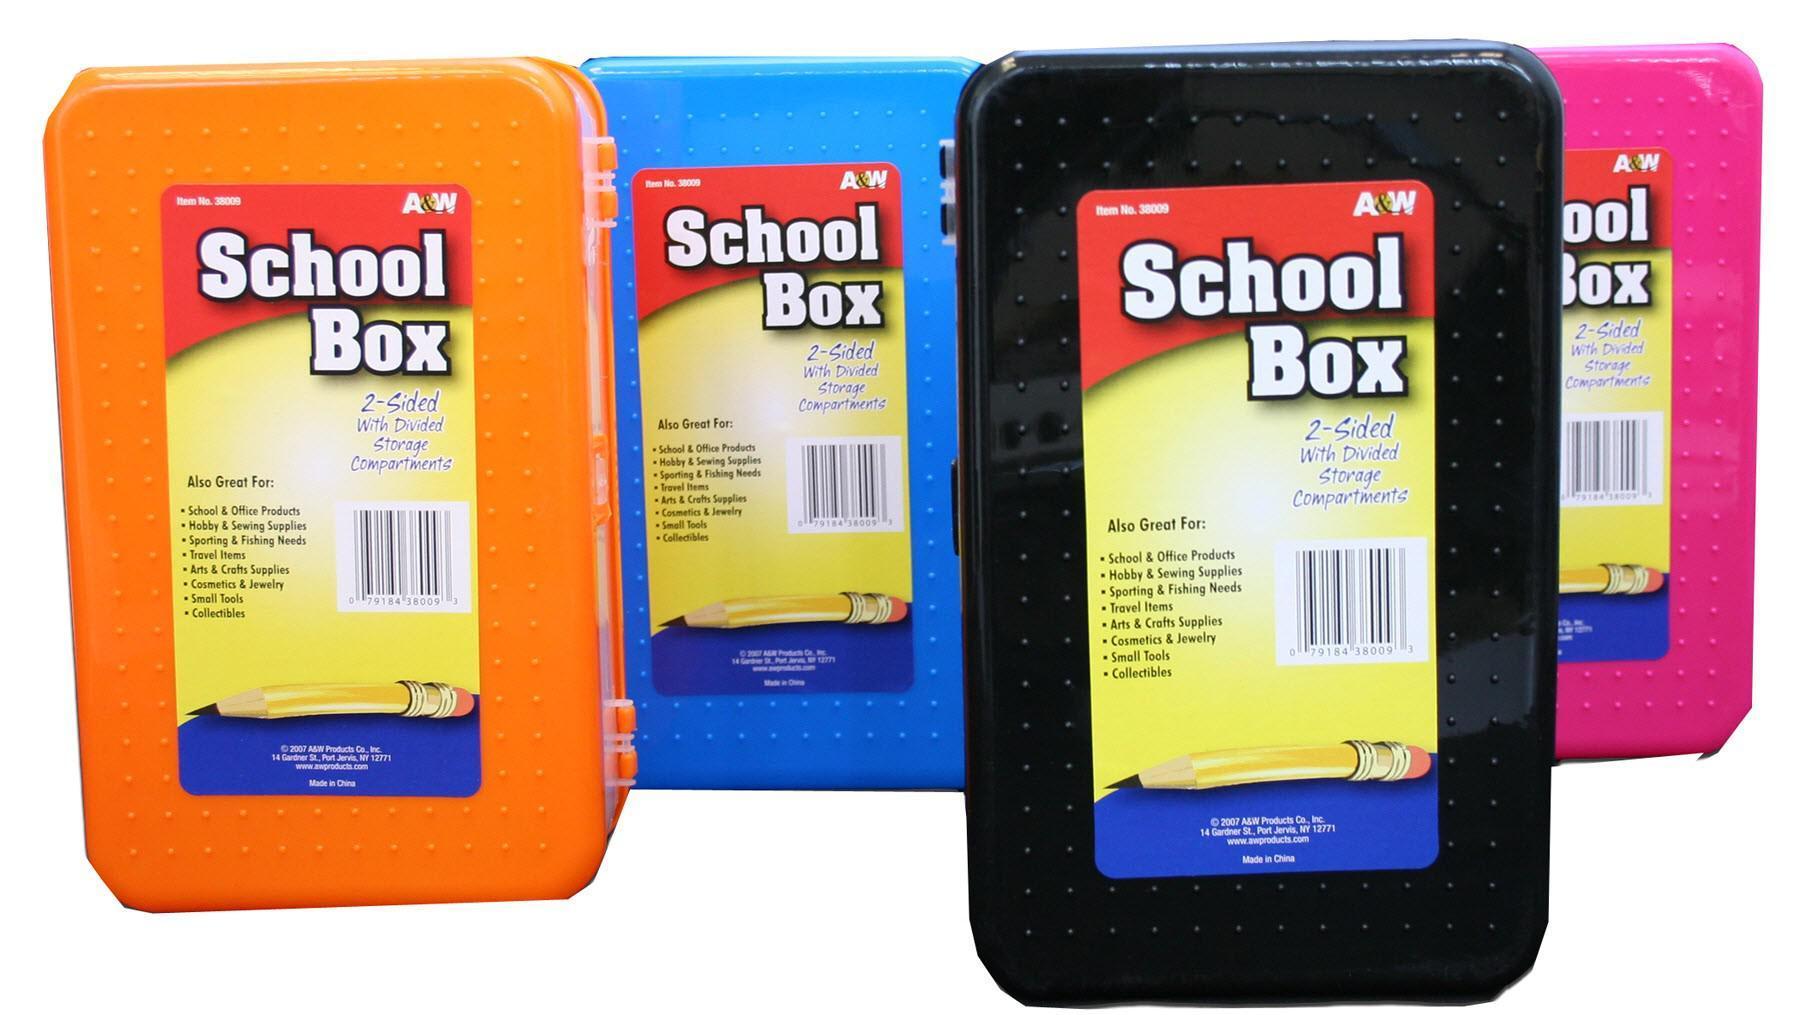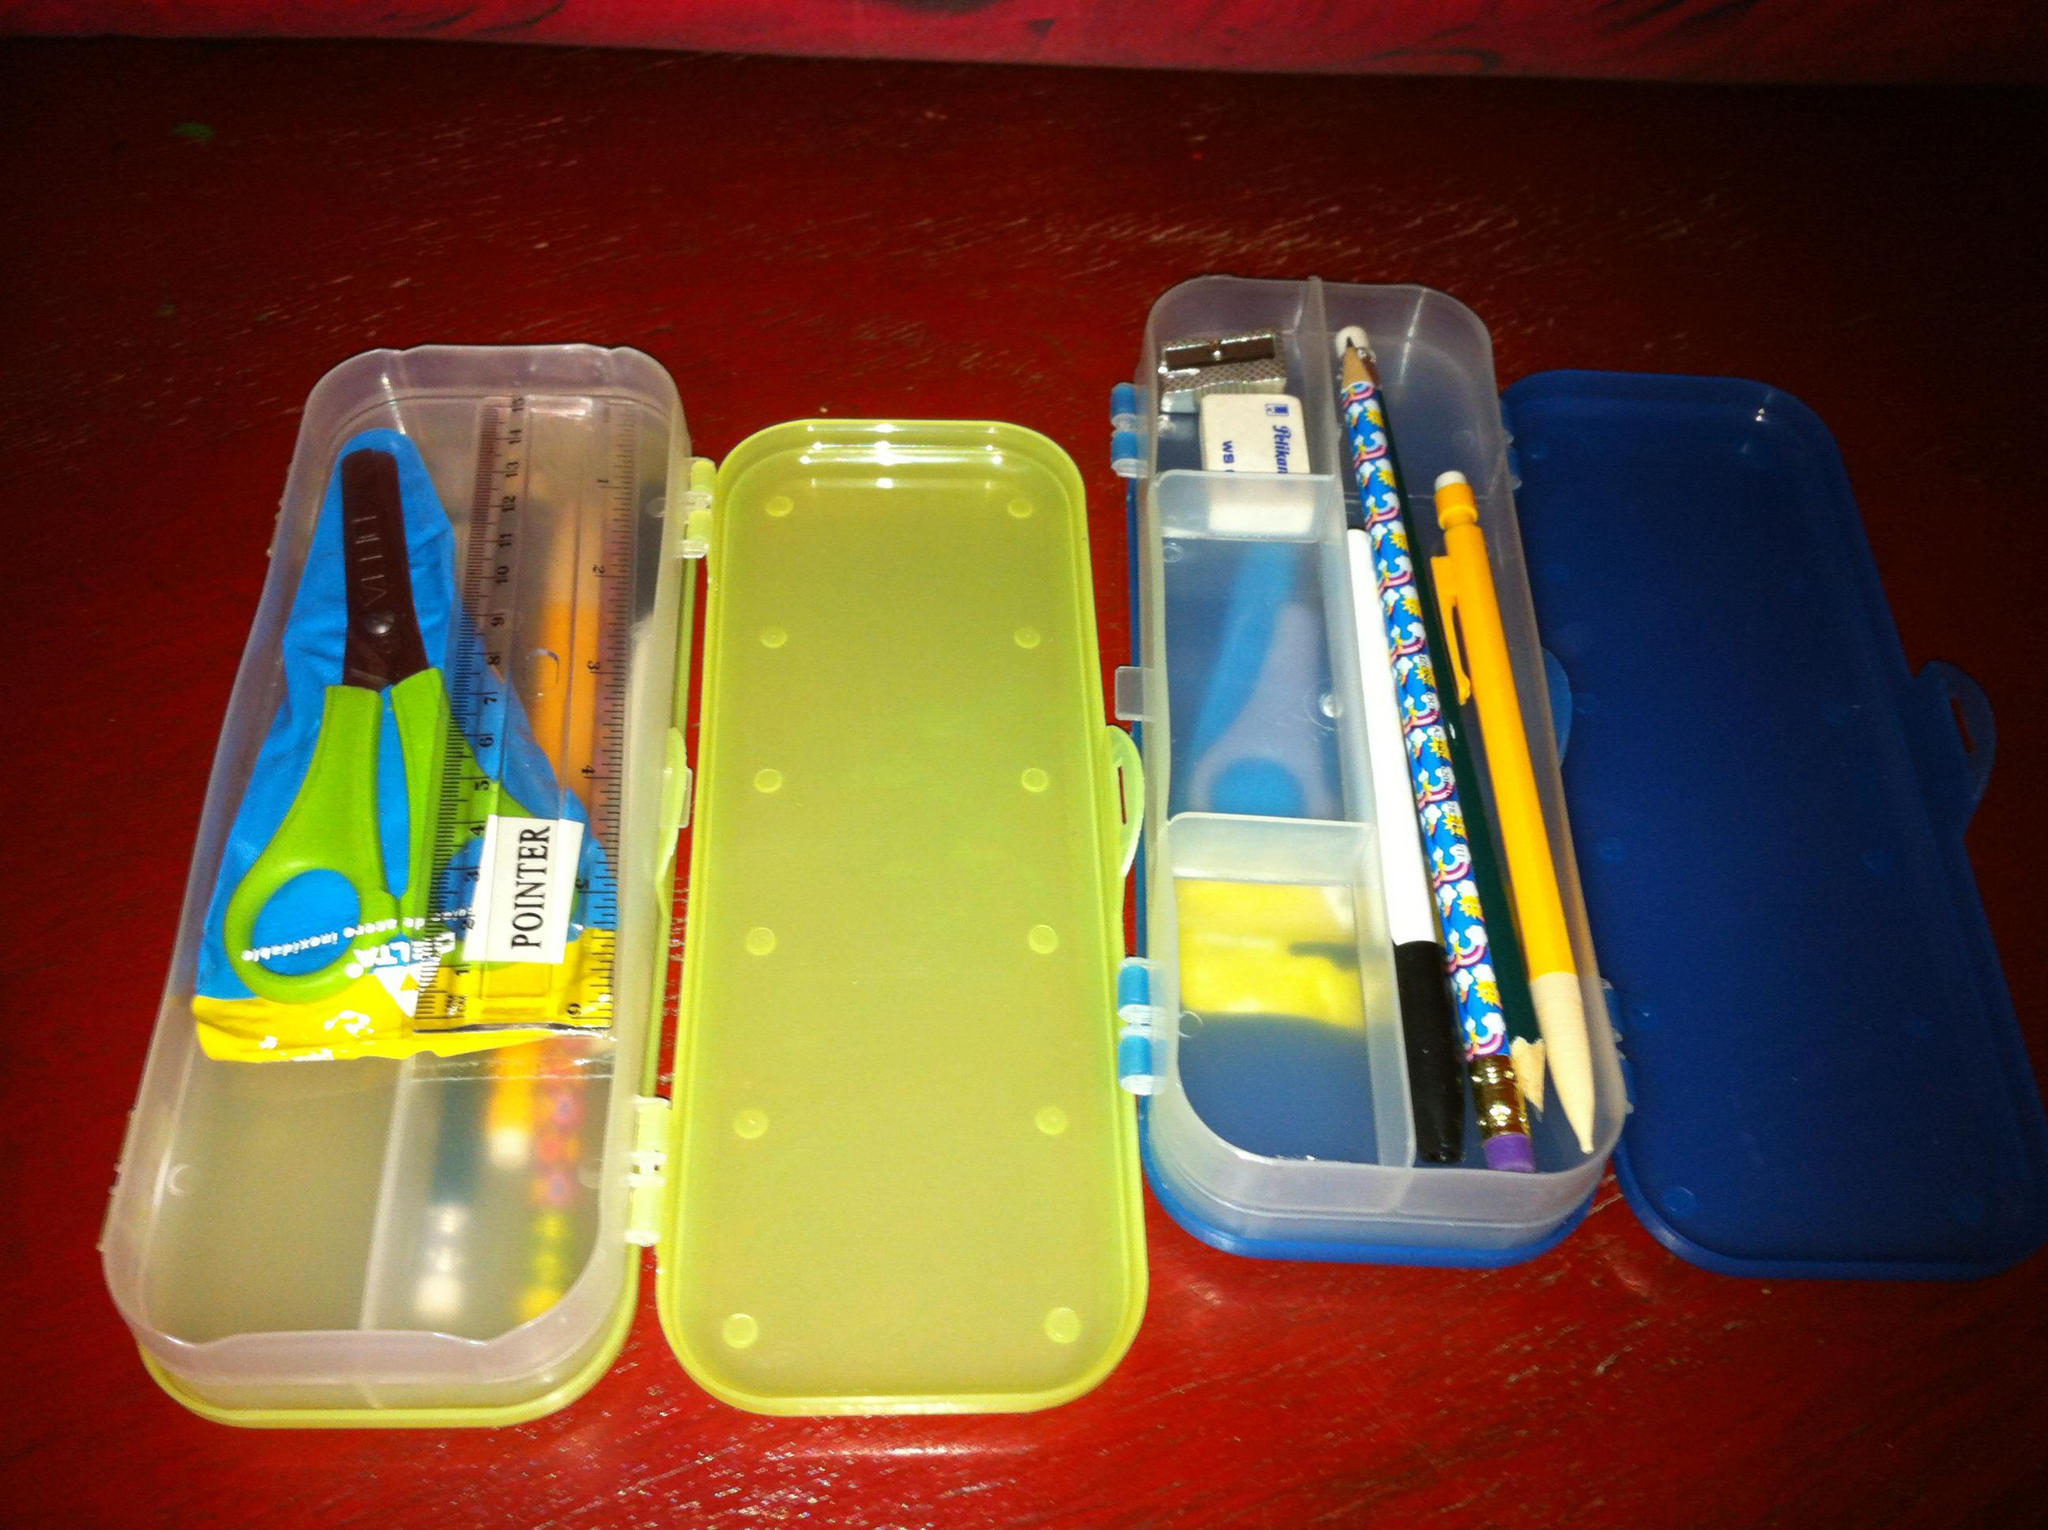The first image is the image on the left, the second image is the image on the right. For the images shown, is this caption "There is at most two pencil holders." true? Answer yes or no. No. The first image is the image on the left, the second image is the image on the right. Considering the images on both sides, is "At least one image shows a pencil case decorated with an animated scene inspired by a kids' movie." valid? Answer yes or no. No. 